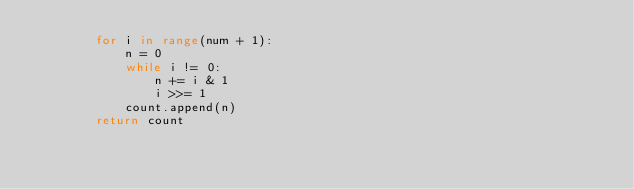<code> <loc_0><loc_0><loc_500><loc_500><_Python_>        for i in range(num + 1):
            n = 0
            while i != 0:
                n += i & 1
                i >>= 1
            count.append(n)
        return count</code> 